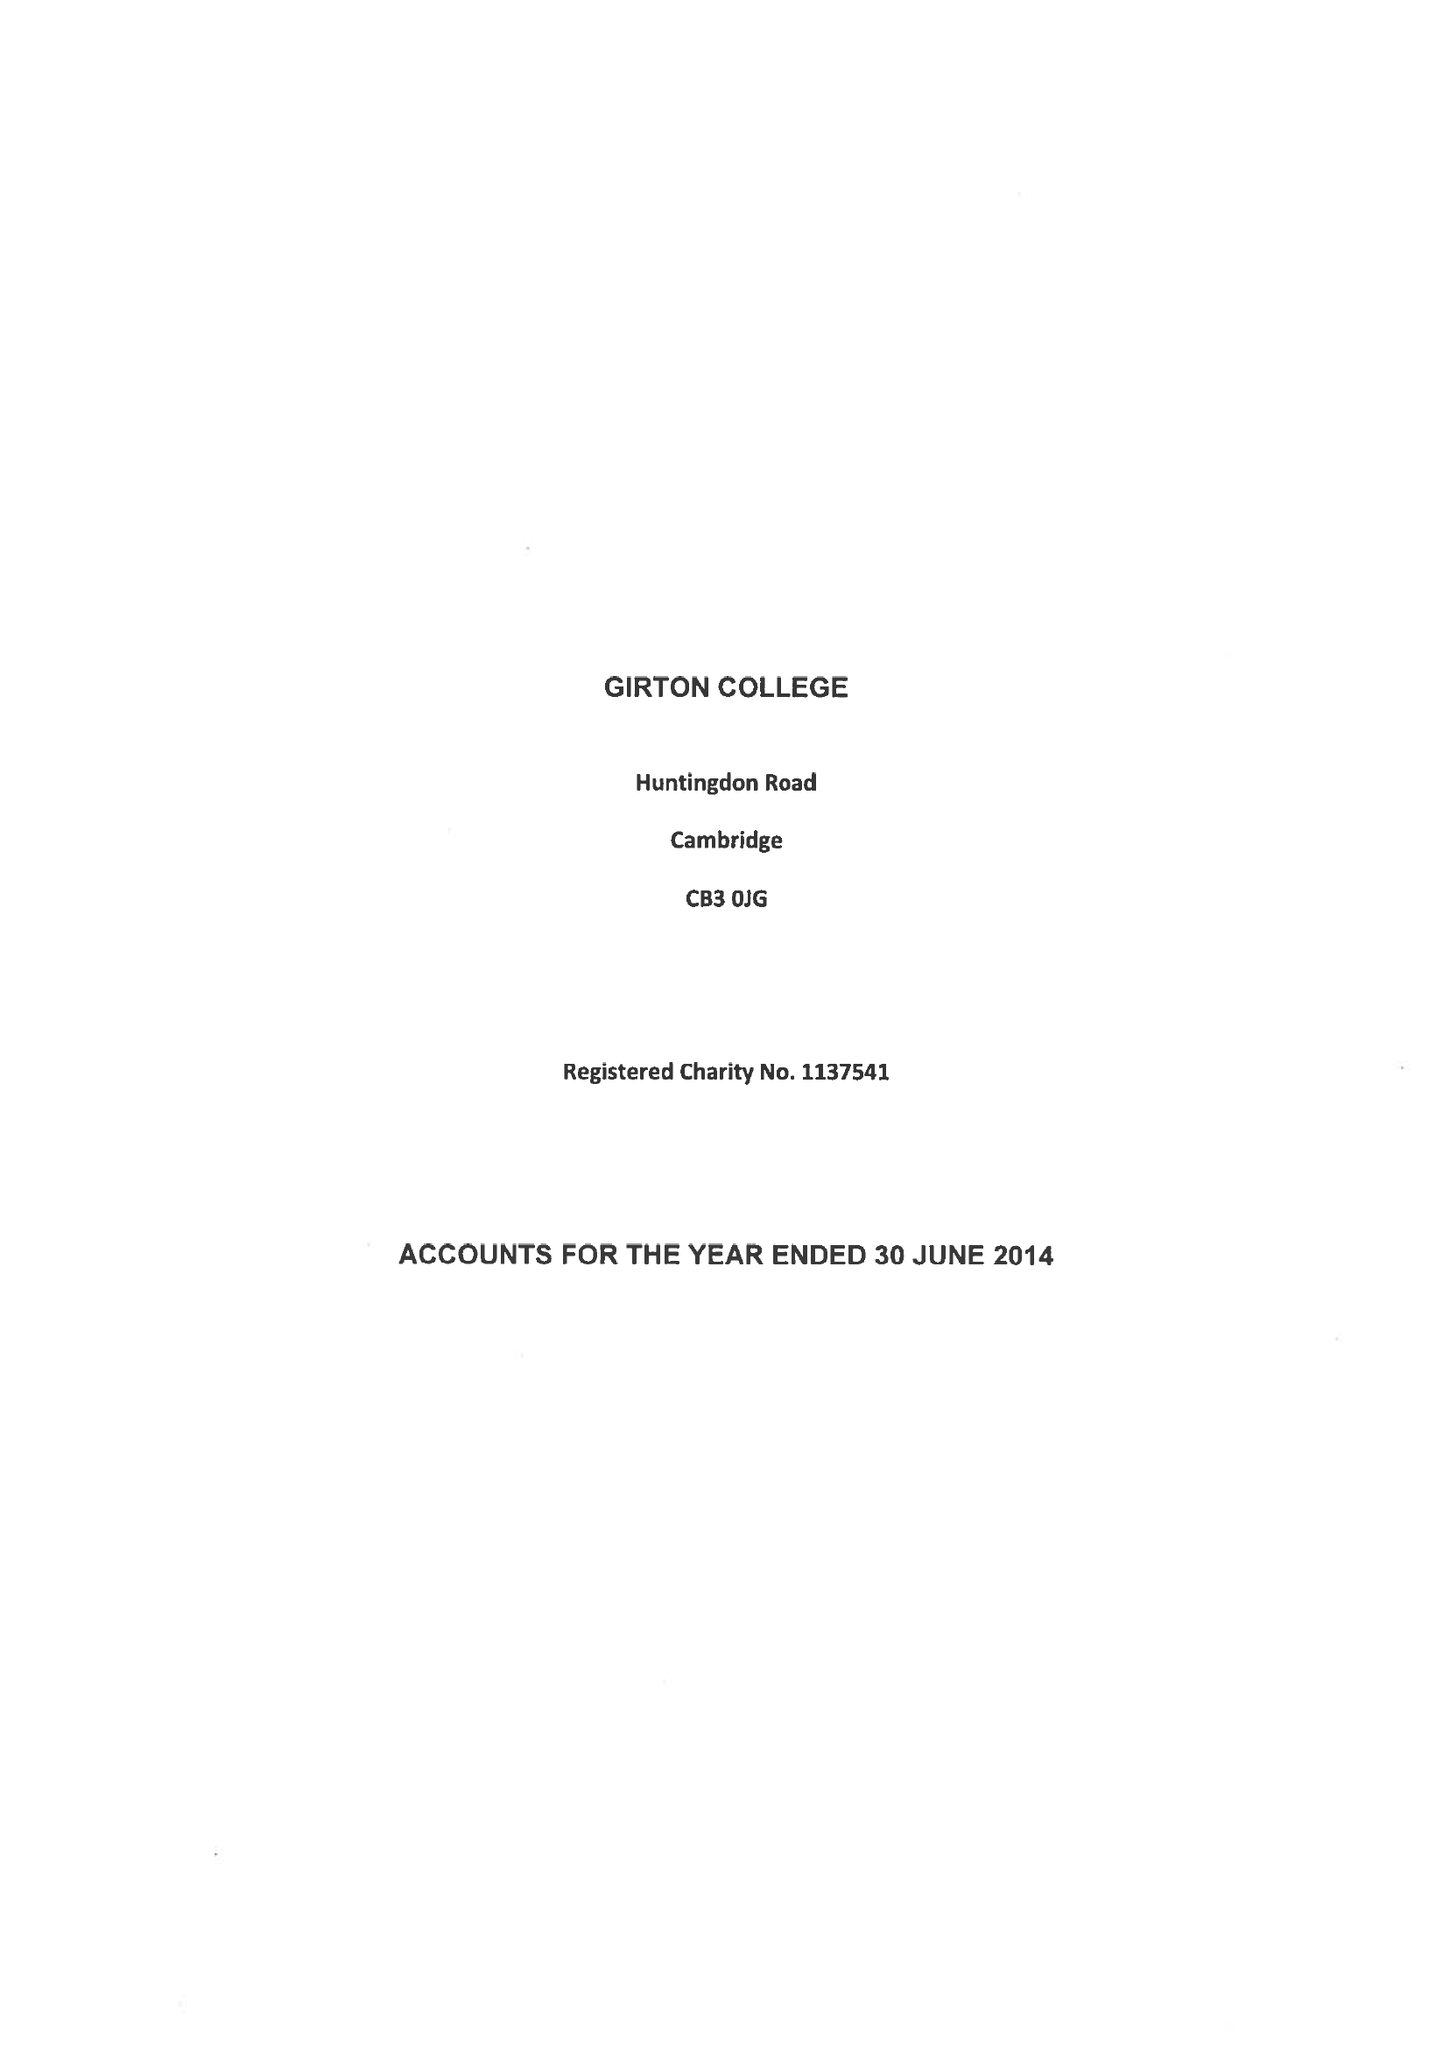What is the value for the report_date?
Answer the question using a single word or phrase. 2014-06-30 